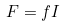<formula> <loc_0><loc_0><loc_500><loc_500>F = f I</formula> 